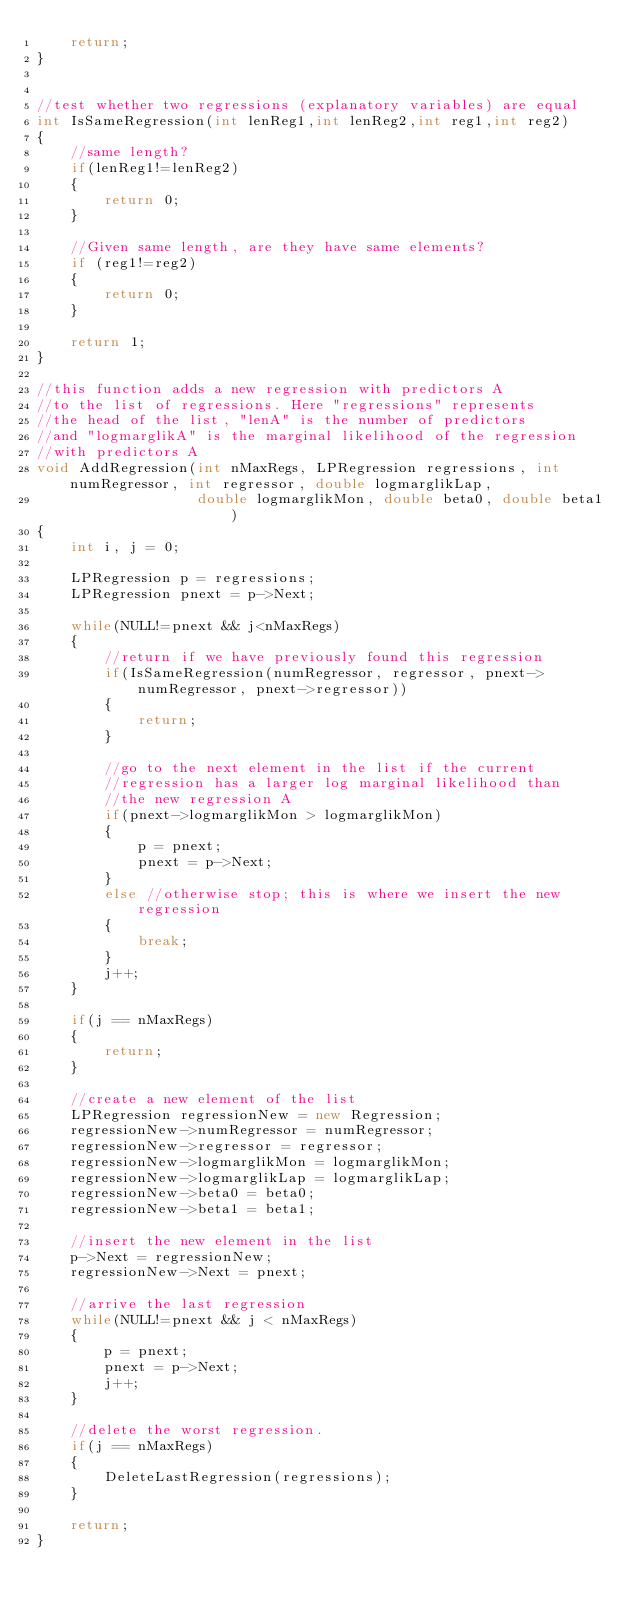Convert code to text. <code><loc_0><loc_0><loc_500><loc_500><_C++_>    return;
}


//test whether two regressions (explanatory variables) are equal
int IsSameRegression(int lenReg1,int lenReg2,int reg1,int reg2)
{
    //same length?
    if(lenReg1!=lenReg2)
    {
        return 0;
    }
    
    //Given same length, are they have same elements?
    if (reg1!=reg2)
    {
        return 0;
    }
    
    return 1;
}

//this function adds a new regression with predictors A
//to the list of regressions. Here "regressions" represents
//the head of the list, "lenA" is the number of predictors
//and "logmarglikA" is the marginal likelihood of the regression
//with predictors A
void AddRegression(int nMaxRegs, LPRegression regressions, int numRegressor, int regressor, double logmarglikLap,
                   double logmarglikMon, double beta0, double beta1)
{
    int i, j = 0;
    
    LPRegression p = regressions;
    LPRegression pnext = p->Next;
    
    while(NULL!=pnext && j<nMaxRegs)
    {
        //return if we have previously found this regression
        if(IsSameRegression(numRegressor, regressor, pnext->numRegressor, pnext->regressor))
        {
            return;
        }
        
        //go to the next element in the list if the current
        //regression has a larger log marginal likelihood than
        //the new regression A
        if(pnext->logmarglikMon > logmarglikMon)
        {
            p = pnext;
            pnext = p->Next;
        }
        else //otherwise stop; this is where we insert the new regression
        {
            break;
        }
        j++;
    }
    
    if(j == nMaxRegs)
    {
        return;
    }
    
    //create a new element of the list
    LPRegression regressionNew = new Regression;
    regressionNew->numRegressor = numRegressor;
    regressionNew->regressor = regressor;
    regressionNew->logmarglikMon = logmarglikMon;
    regressionNew->logmarglikLap = logmarglikLap;
    regressionNew->beta0 = beta0;
    regressionNew->beta1 = beta1;
    
    //insert the new element in the list
    p->Next = regressionNew;
    regressionNew->Next = pnext;
    
    //arrive the last regression
    while(NULL!=pnext && j < nMaxRegs)
    {
        p = pnext;
        pnext = p->Next;
        j++;
    }
    
    //delete the worst regression.
    if(j == nMaxRegs)
    {
        DeleteLastRegression(regressions);
    }
    
    return;
}
</code> 